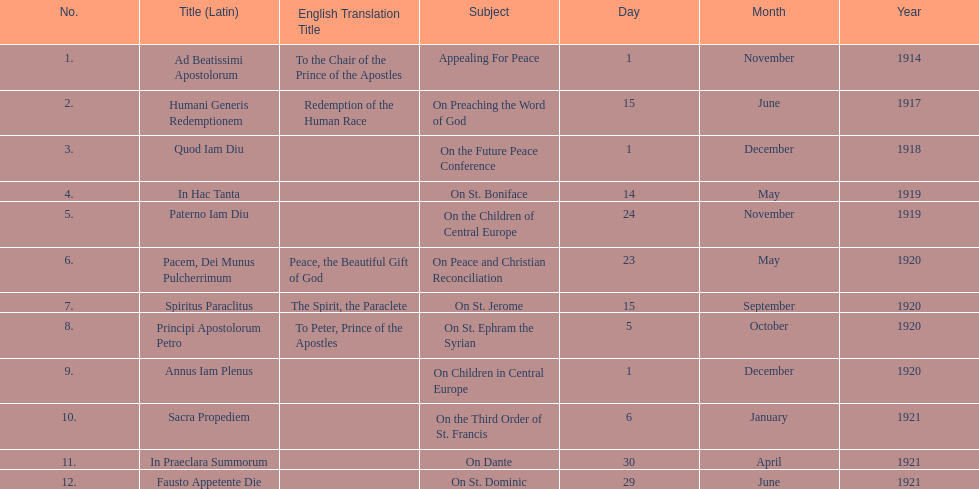What is the total number of encyclicals to take place in december? 2. 